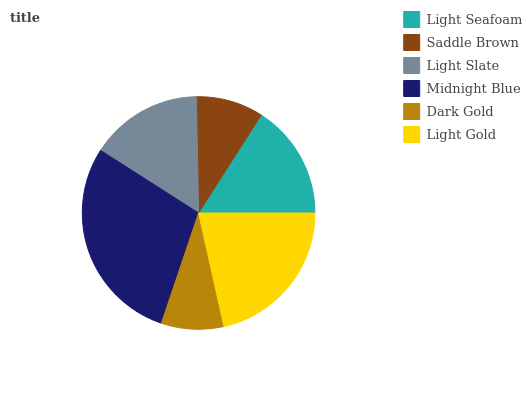Is Dark Gold the minimum?
Answer yes or no. Yes. Is Midnight Blue the maximum?
Answer yes or no. Yes. Is Saddle Brown the minimum?
Answer yes or no. No. Is Saddle Brown the maximum?
Answer yes or no. No. Is Light Seafoam greater than Saddle Brown?
Answer yes or no. Yes. Is Saddle Brown less than Light Seafoam?
Answer yes or no. Yes. Is Saddle Brown greater than Light Seafoam?
Answer yes or no. No. Is Light Seafoam less than Saddle Brown?
Answer yes or no. No. Is Light Seafoam the high median?
Answer yes or no. Yes. Is Light Slate the low median?
Answer yes or no. Yes. Is Saddle Brown the high median?
Answer yes or no. No. Is Dark Gold the low median?
Answer yes or no. No. 